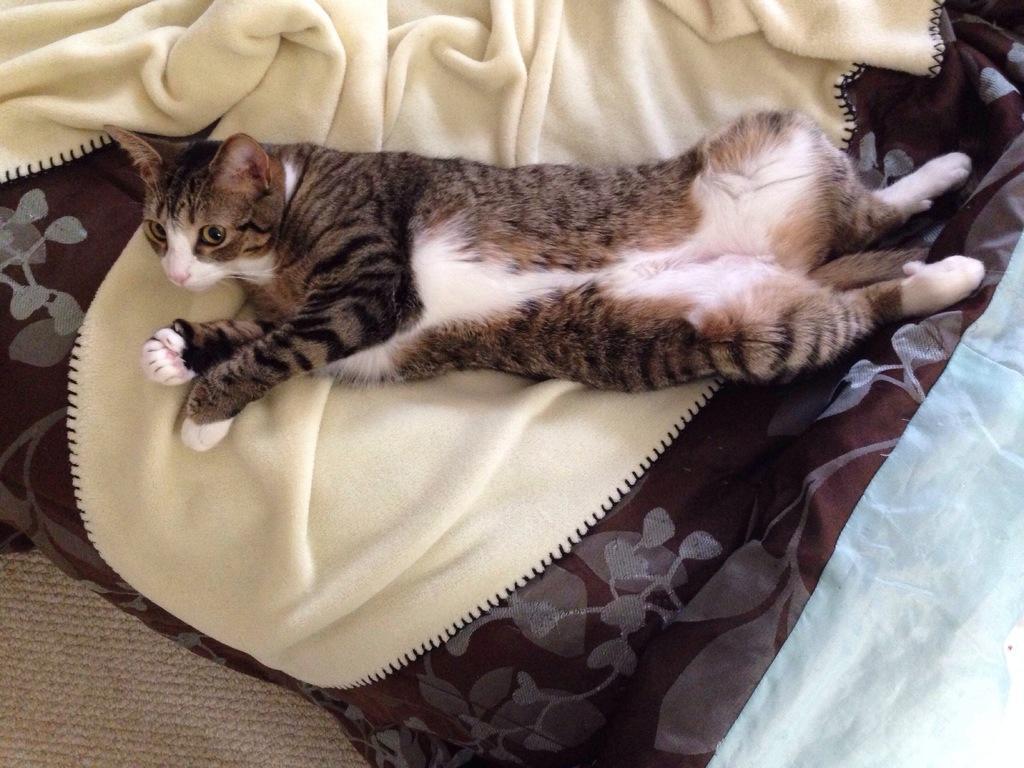Please provide a concise description of this image. In this image we can see a black and white color cat is lying on the surface of sofa and one yellow color blanket is there. 